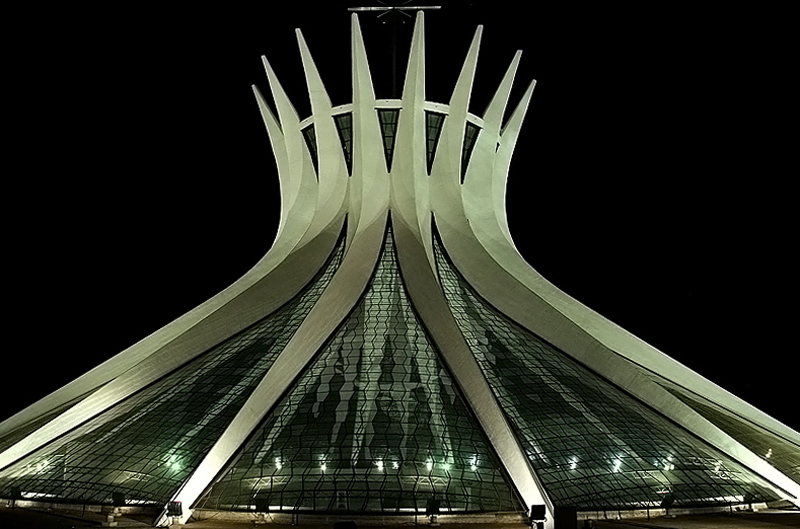What is the exposure like in the image? The image appears to be well-exposed overall, with subtle areas potentially leaning towards overexposure around the illuminated parts of the structure. However, these do not significantly detract from the overall quality and detail visible throughout the photo, including the textures on the building's surface and the surrounding darkness. 